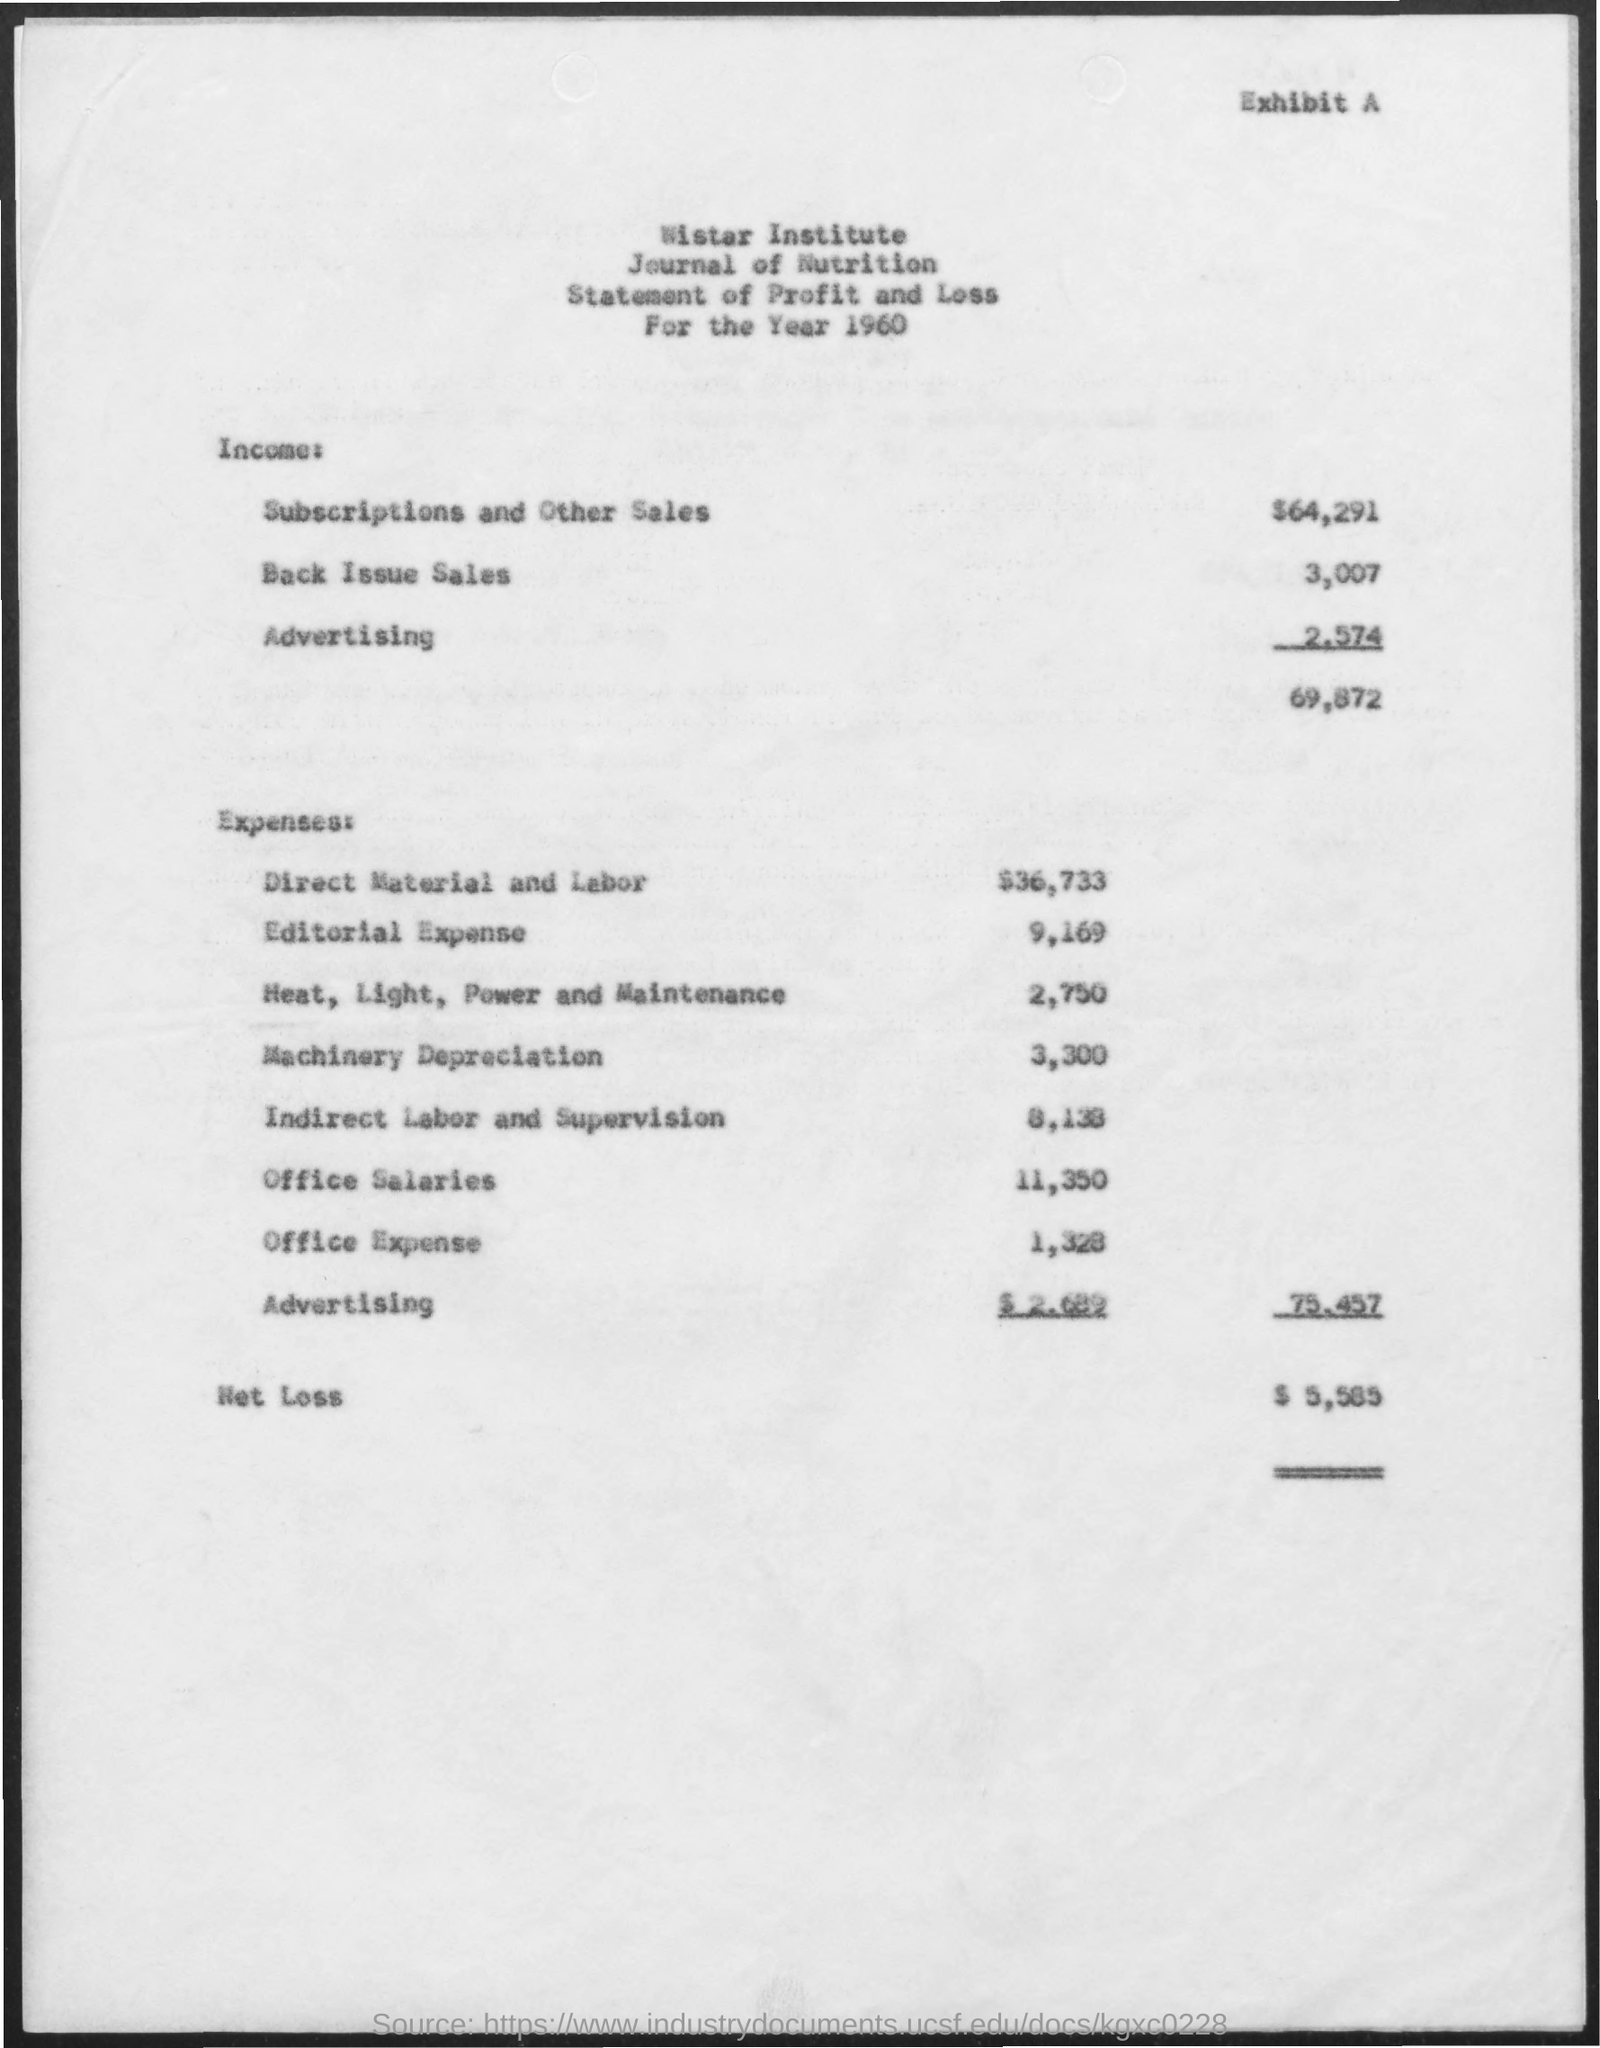Point out several critical features in this image. The income from back issue sales is 3,007. The income from subscriptions and other sales was $64,291. The net loss is $5,585. The office expense is 1,328. 